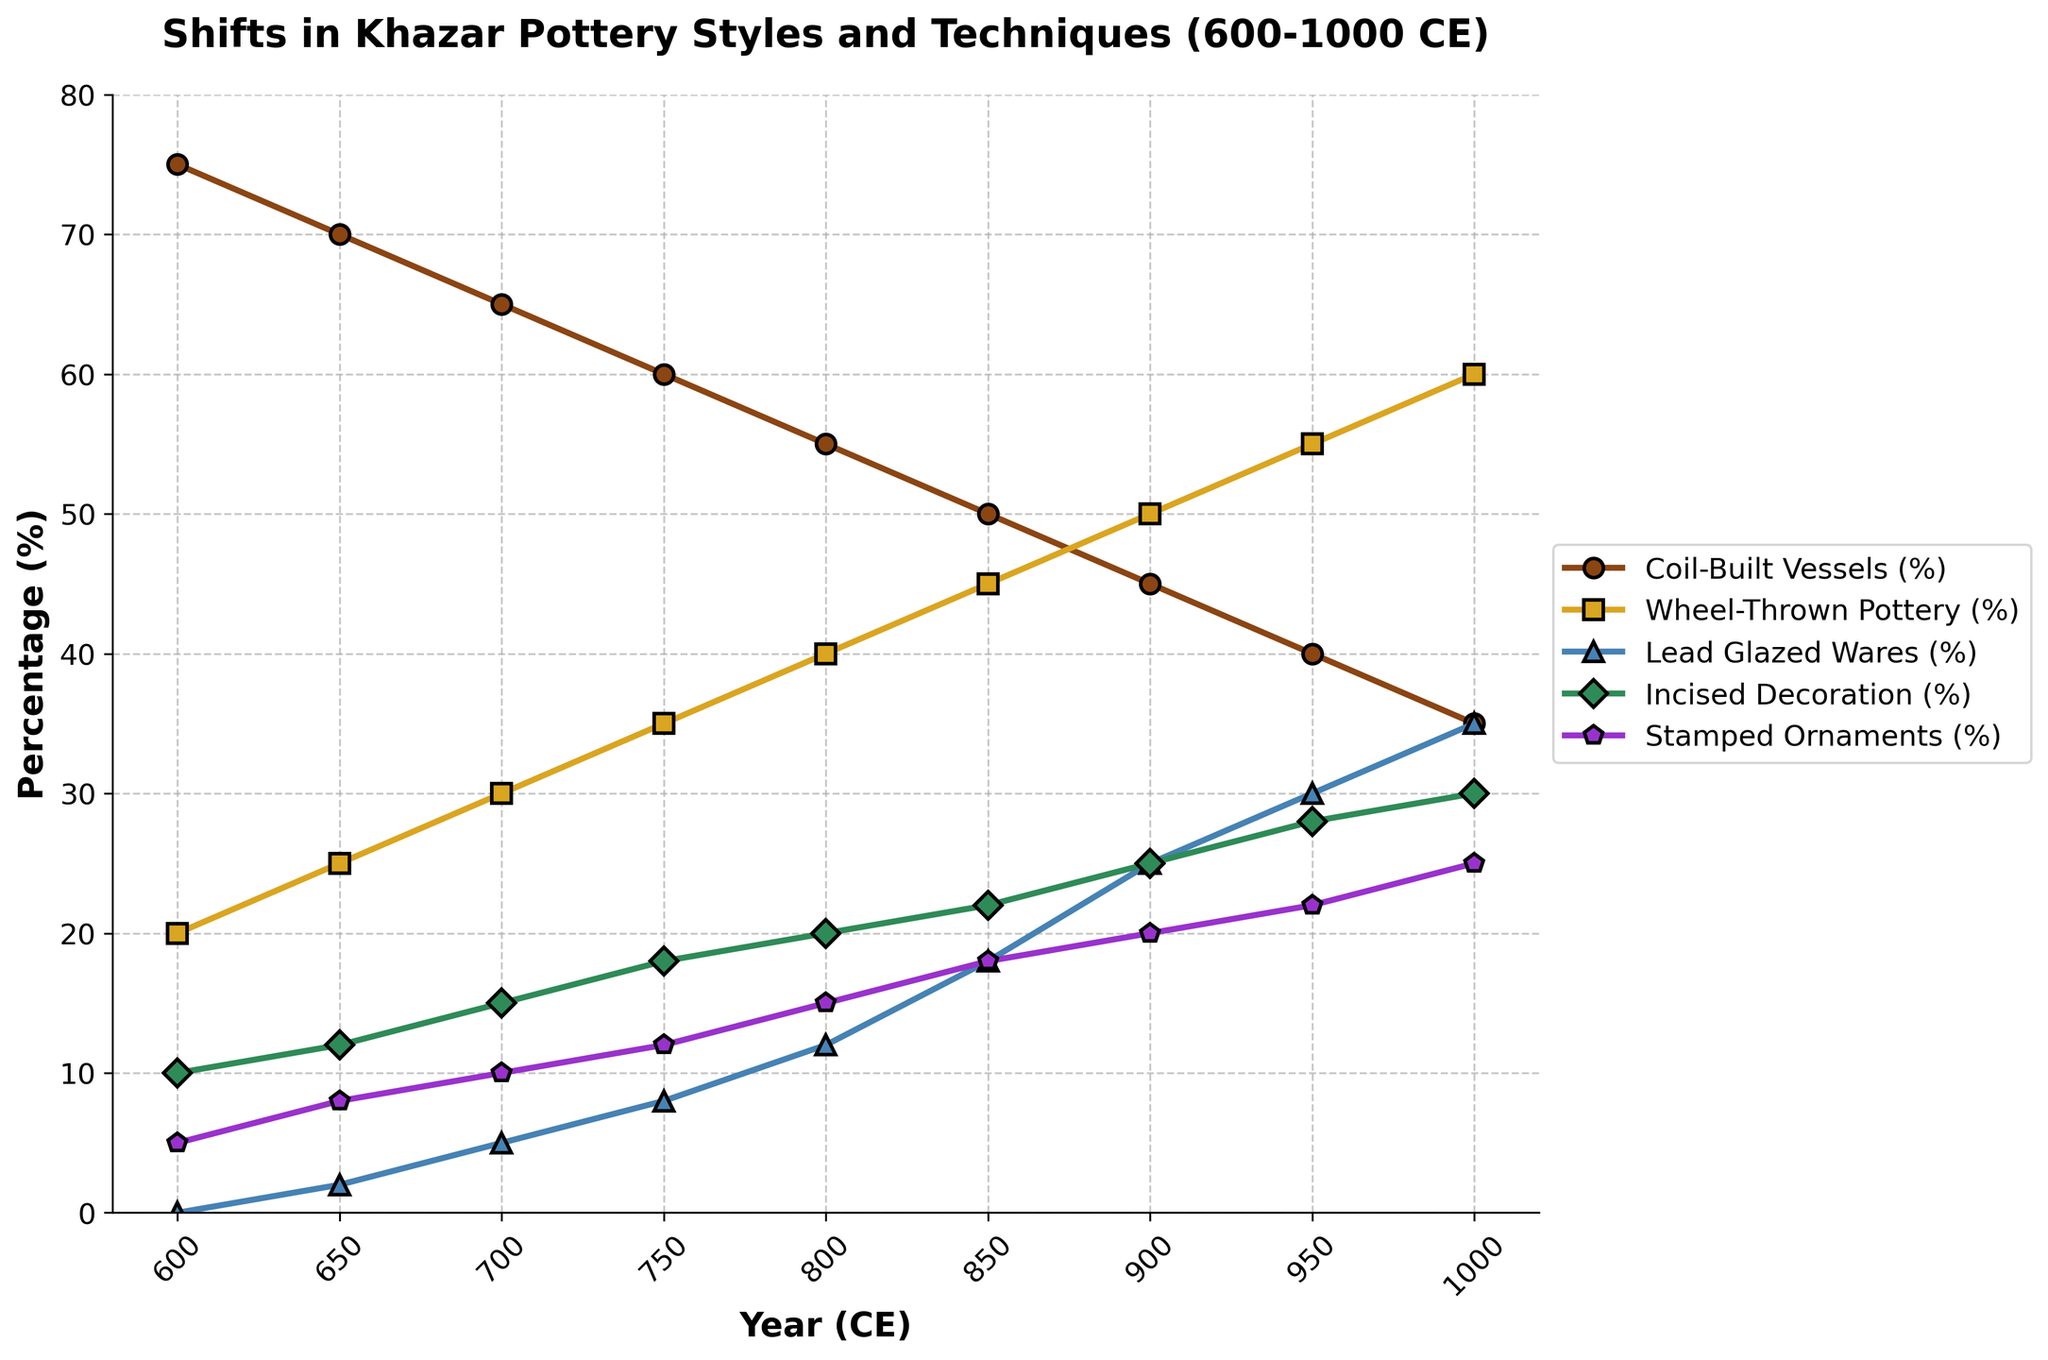What year does Coil-Built Vessels percentage first fall below 50%? In the plot, we observe the line for Coil-Built Vessels (%). It first falls below 50% in the year 850 CE.
Answer: 850 CE During which period does Wheel-Thrown Pottery's percentage increase the most? By examining the slope of the Wheel-Thrown Pottery line, we can notice that the steepest increase occurs between 800 CE and 850 CE, where it increases by 5 percentage points.
Answer: 800-850 CE What is the net change in the percentage of Lead Glazed Wares from 600 to 1000 CE? The plot shows that Lead Glazed Wares start at 0% in 600 CE and rise to 35% by 1000 CE. The net change is 35% - 0% = 35%.
Answer: 35% Compare the relative trends of Incised Decoration (%) and Stamped Ornaments (%) between 650 and 750 CE. Which has a steeper increase? Analyzing the lines, Incised Decoration rises from 12% to 18% (a 6 percentage points increase) while Stamped Ornaments rise from 8% to 12% (a 4 percentage points increase). So, Incised Decoration has a steeper increase.
Answer: Incised Decoration Which pottery style ends with the highest percentage in 1000 CE? Observing the endpoints of all the lines, Wheel-Thrown Pottery ends at 60%, which is the highest among all styles in 1000 CE.
Answer: Wheel-Thrown Pottery What is the percentage difference between Coil-Built Vessels and Wheel-Thrown Pottery in the year 950 CE? In 950 CE, Coil-Built Vessels are at 40% while Wheel-Thrown Pottery is at 55%. The percentage difference is 55% - 40% = 15%.
Answer: 15% Which pottery style shows the least amount of change from 600 to 1000 CE? By evaluating the changes over the entire period, Stamped Ornaments start at 5% and end at 25%, showing a net increase of 20. Other styles have higher changes.
Answer: Stamped Ornaments How does the percentage of Incised Decoration in 700 CE compare to that of Lead Glazed Wares in the same year? In 700 CE, Incised Decoration is at 15% and Lead Glazed Wares are at 5%. Incised Decoration is higher by 10 percentage points.
Answer: Incised Decoration is higher What is the average percentage of Coil-Built Vessels over the entire period? Summing the percentages of Coil-Built Vessels (75+70+65+60+55+50+45+40+35) gives 495. Dividing by the number of points, 495/9, results in the average being 55%.
Answer: 55% Does any pottery style reach a percentage of 0 or 100 at any point from 600 to 1000 CE? None of the lines for the pottery styles and techniques reach 0 or 100 at any point in the plot. The minimum observed is 0% for Lead Glazed Wares at 600 CE, but no lines go lower or hit 100% at any point.
Answer: No 